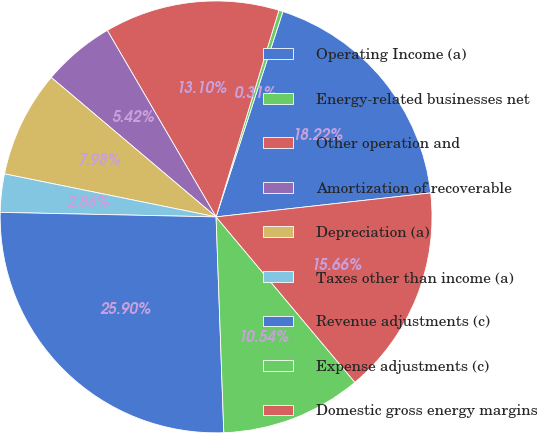Convert chart to OTSL. <chart><loc_0><loc_0><loc_500><loc_500><pie_chart><fcel>Operating Income (a)<fcel>Energy-related businesses net<fcel>Other operation and<fcel>Amortization of recoverable<fcel>Depreciation (a)<fcel>Taxes other than income (a)<fcel>Revenue adjustments (c)<fcel>Expense adjustments (c)<fcel>Domestic gross energy margins<nl><fcel>18.22%<fcel>0.31%<fcel>13.1%<fcel>5.42%<fcel>7.98%<fcel>2.86%<fcel>25.9%<fcel>10.54%<fcel>15.66%<nl></chart> 